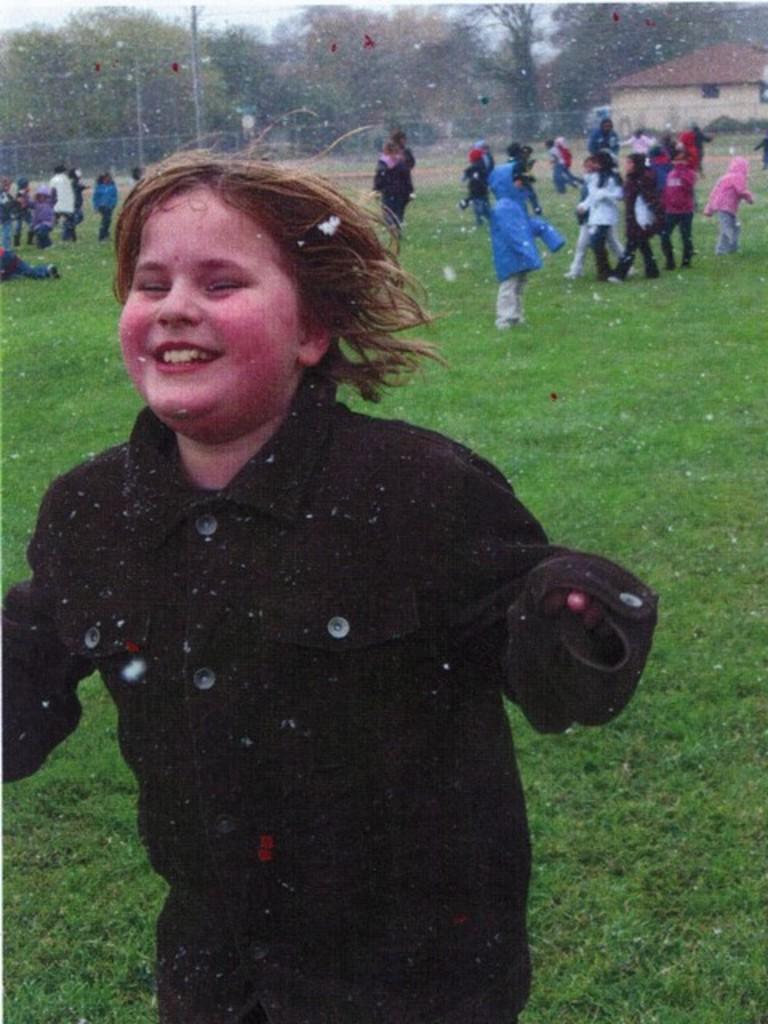Could you give a brief overview of what you see in this image? There is one person standing and wearing a black color dress in the middle of this image. There are some other persons standing on a grassy land in the background. There is a fencing beside to this persons. There are some trees at the top of this image and there is a house at the top right side of this image. 